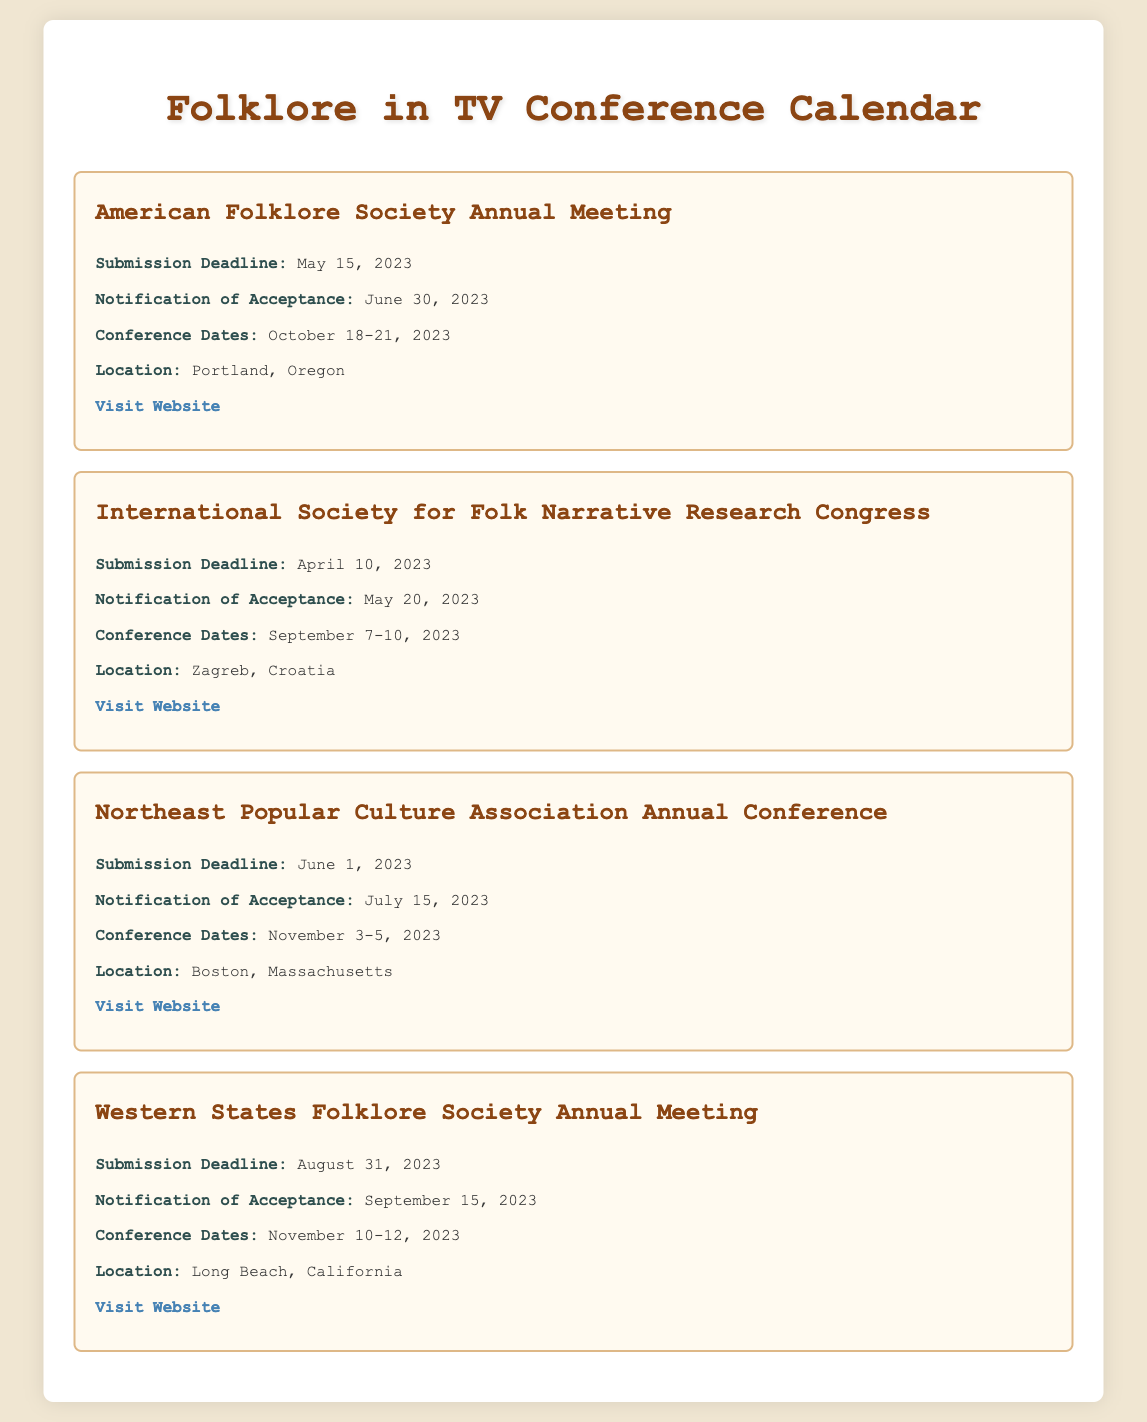What is the submission deadline for the American Folklore Society Annual Meeting? The submission deadline for the American Folklore Society Annual Meeting is stated in the document.
Answer: May 15, 2023 What is the location of the International Society for Folk Narrative Research Congress? The location is explicitly mentioned in the details for the International Society for Folk Narrative Research Congress.
Answer: Zagreb, Croatia How many days are between the notification of acceptance and the conference dates for the Northeast Popular Culture Association Annual Conference? The acceptance notification date is July 15, 2023, and the conference starts on November 3, 2023, which requires calculating the difference in days.
Answer: 110 days When does the Western States Folklore Society Annual Meeting take place? The document provides the specific dates for the conference.
Answer: November 10-12, 2023 What is the notification of acceptance date for the International Society for Folk Narrative Research Congress? This specific date is listed in the event details.
Answer: May 20, 2023 Name one conference that takes place in 2023 after June. The conferences listed include their dates, and one example can be easily identified.
Answer: Northeast Popular Culture Association Annual Conference What is the total number of events listed in the calendar? The events are broken down into individual sections based on the formatted structure, allowing for counting.
Answer: 4 events What is the submission deadline for the Western States Folklore Society Annual Meeting? The specific date is given in the details of that event.
Answer: August 31, 2023 What conference occurs last in the year 2023 according to the document? The document outlines multiple conferences along with their dates, helping to identify the last one.
Answer: Western States Folklore Society Annual Meeting 